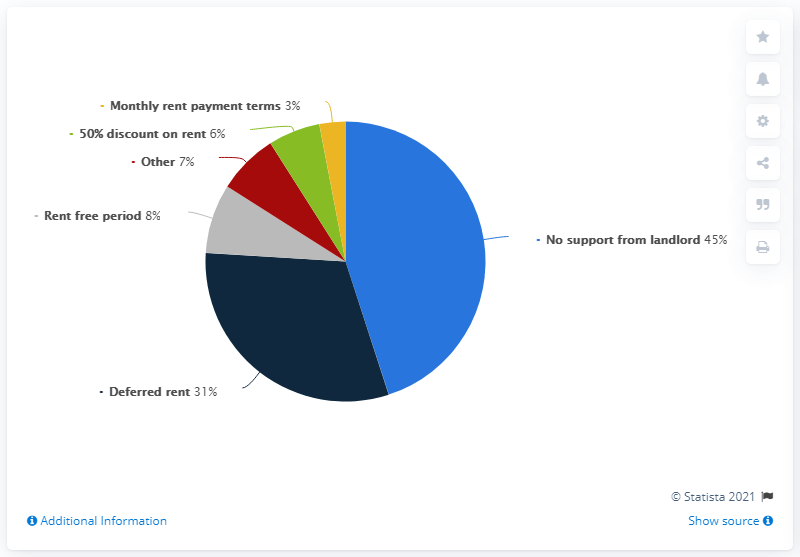Specify some key components in this picture. The most common response in the chart is that tenants do not receive support from their landlord. The specific supports from the chart total 48. A third of businesses received a deferred rent agreement with their landlord, according to a recent study. 